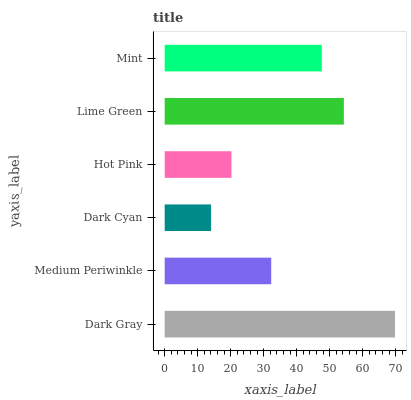Is Dark Cyan the minimum?
Answer yes or no. Yes. Is Dark Gray the maximum?
Answer yes or no. Yes. Is Medium Periwinkle the minimum?
Answer yes or no. No. Is Medium Periwinkle the maximum?
Answer yes or no. No. Is Dark Gray greater than Medium Periwinkle?
Answer yes or no. Yes. Is Medium Periwinkle less than Dark Gray?
Answer yes or no. Yes. Is Medium Periwinkle greater than Dark Gray?
Answer yes or no. No. Is Dark Gray less than Medium Periwinkle?
Answer yes or no. No. Is Mint the high median?
Answer yes or no. Yes. Is Medium Periwinkle the low median?
Answer yes or no. Yes. Is Dark Gray the high median?
Answer yes or no. No. Is Lime Green the low median?
Answer yes or no. No. 